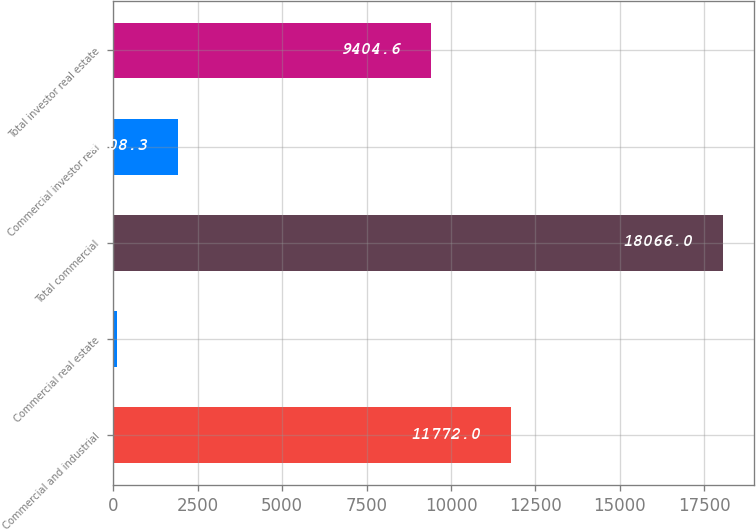<chart> <loc_0><loc_0><loc_500><loc_500><bar_chart><fcel>Commercial and industrial<fcel>Commercial real estate<fcel>Total commercial<fcel>Commercial investor real<fcel>Total investor real estate<nl><fcel>11772<fcel>113<fcel>18066<fcel>1908.3<fcel>9404.6<nl></chart> 